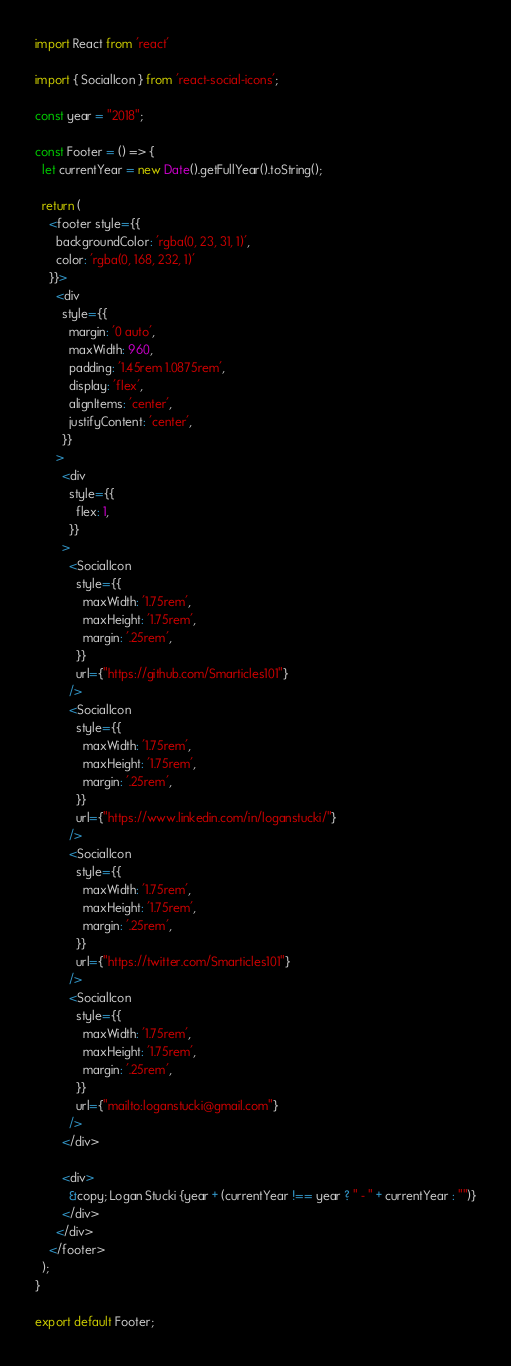<code> <loc_0><loc_0><loc_500><loc_500><_JavaScript_>import React from 'react'

import { SocialIcon } from 'react-social-icons';

const year = "2018";

const Footer = () => {
  let currentYear = new Date().getFullYear().toString();

  return (
    <footer style={{
      backgroundColor: 'rgba(0, 23, 31, 1)',
      color: 'rgba(0, 168, 232, 1)'
    }}>
      <div
        style={{
          margin: '0 auto',
          maxWidth: 960,
          padding: '1.45rem 1.0875rem',
          display: 'flex',
          alignItems: 'center',
          justifyContent: 'center',
        }}
      >
        <div
          style={{
            flex: 1,
          }}
        >
          <SocialIcon 
            style={{
              maxWidth: '1.75rem',
              maxHeight: '1.75rem',
              margin: '.25rem',
            }}
            url={"https://github.com/Smarticles101"}
          />
          <SocialIcon 
            style={{
              maxWidth: '1.75rem',
              maxHeight: '1.75rem',
              margin: '.25rem',
            }}
            url={"https://www.linkedin.com/in/loganstucki/"}
          />
          <SocialIcon 
            style={{
              maxWidth: '1.75rem',
              maxHeight: '1.75rem',
              margin: '.25rem',
            }}
            url={"https://twitter.com/Smarticles101"}
          />
          <SocialIcon 
            style={{
              maxWidth: '1.75rem',
              maxHeight: '1.75rem',
              margin: '.25rem',
            }}
            url={"mailto:loganstucki@gmail.com"}
          />
        </div>

        <div>
          &copy; Logan Stucki {year + (currentYear !== year ? " - " + currentYear : "")}
        </div>
      </div>
    </footer>
  );
}

export default Footer;
</code> 